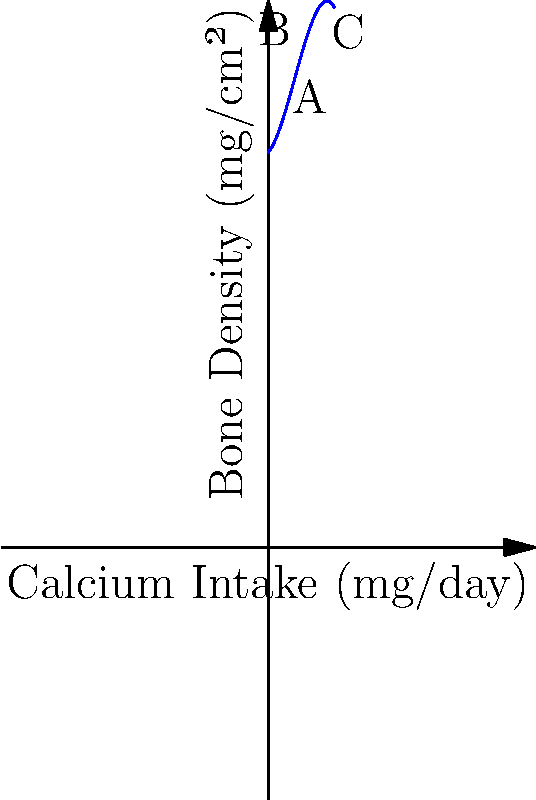The graph shows the relationship between daily calcium intake and bone density in elderly patients. The function is modeled by $f(x) = -0.05x^3 + 0.6x^2 + 1.2x + 60$, where $x$ is the calcium intake in hundreds of mg/day, and $f(x)$ is the bone density in mg/cm². At which point (A, B, or C) does the rate of increase in bone density start to slow down significantly? To determine where the rate of increase in bone density starts to slow down significantly, we need to analyze the rate of change (derivative) of the function:

1. The derivative of $f(x)$ is $f'(x) = -0.15x^2 + 1.2x + 1.2$

2. The second derivative is $f''(x) = -0.3x + 1.2$

3. The point where the rate of increase starts to slow down significantly is where the second derivative changes from positive to negative (inflection point).

4. Set $f''(x) = 0$:
   $-0.3x + 1.2 = 0$
   $-0.3x = -1.2$
   $x = 4$

5. This corresponds to a calcium intake of 400 mg/day.

6. Point A is at x ≈ 2 (200 mg/day), which is before the inflection point.
   Point B is at x = 5 (500 mg/day), which is just after the inflection point.
   Point C is at x = 8 (800 mg/day), which is well after the inflection point.

Therefore, point B is where the rate of increase in bone density starts to slow down significantly.
Answer: B 